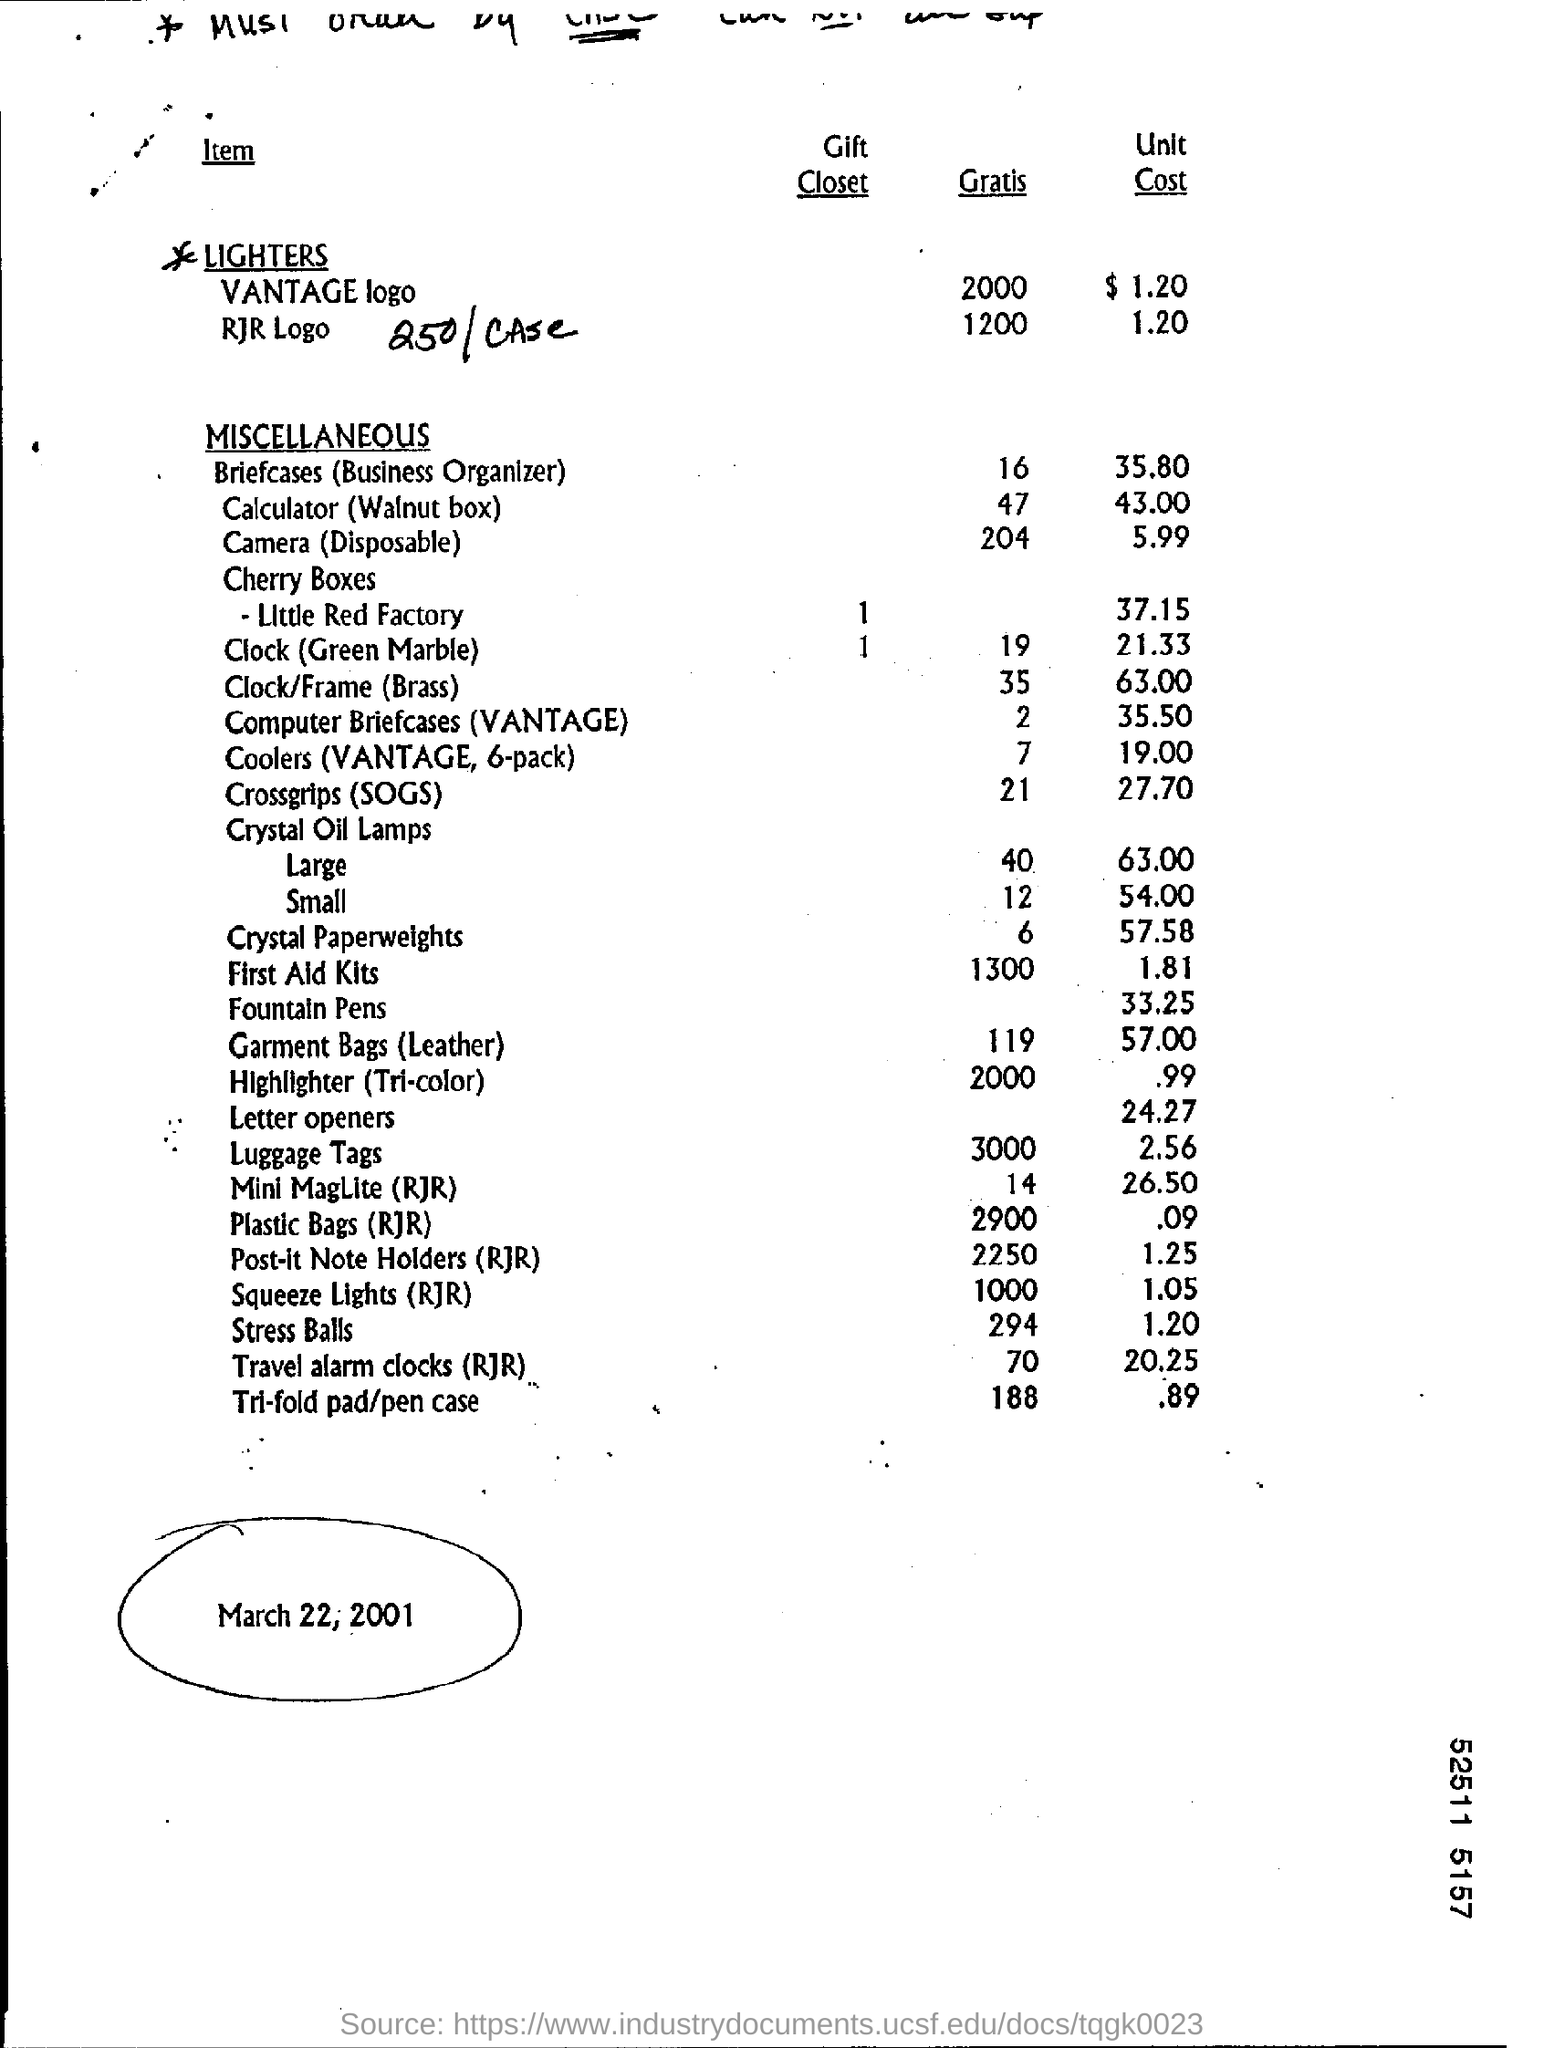What is the date mentioned ?
Your answer should be compact. March 22, 2001. What is the gratis of vantage logo ?
Your answer should be compact. 2000. What is the gratis of briefcases (business organisers )?
Your response must be concise. 16. What is the unit cost of stress ball ?
Provide a short and direct response. 1.20. What is the unit cost of plastic bags (rjr) ?
Give a very brief answer. $ .09. 